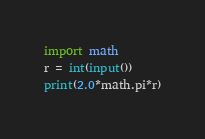<code> <loc_0><loc_0><loc_500><loc_500><_Python_>import math
r = int(input())
print(2.0*math.pi*r)
</code> 